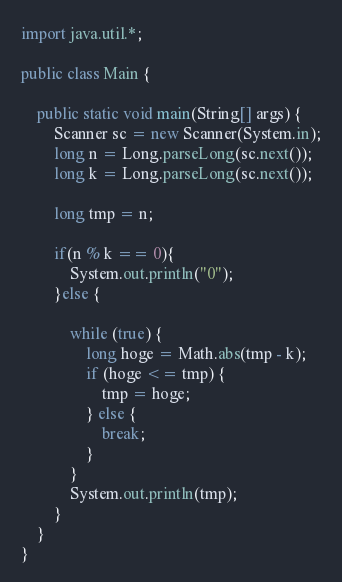Convert code to text. <code><loc_0><loc_0><loc_500><loc_500><_Java_>import java.util.*;

public class Main {

    public static void main(String[] args) {
        Scanner sc = new Scanner(System.in);
        long n = Long.parseLong(sc.next());
        long k = Long.parseLong(sc.next());

        long tmp = n;

        if(n % k == 0){
            System.out.println("0");
        }else {

            while (true) {
                long hoge = Math.abs(tmp - k);
                if (hoge <= tmp) {
                    tmp = hoge;
                } else {
                    break;
                }
            }
            System.out.println(tmp);
        }
    }
}
</code> 